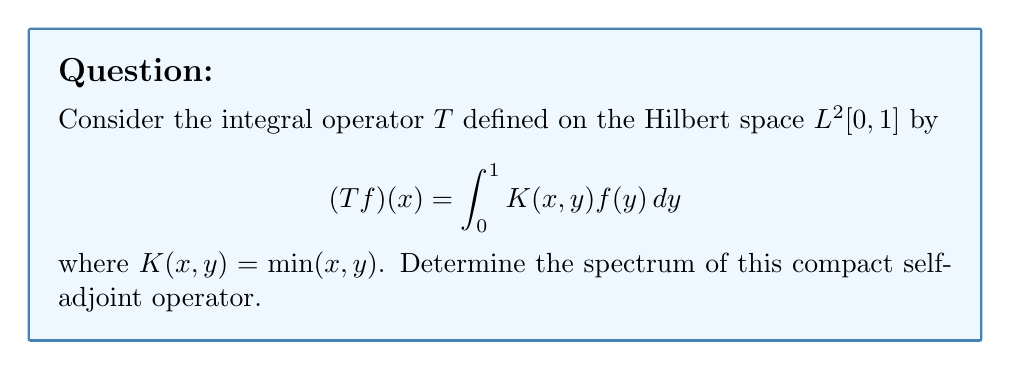Could you help me with this problem? 1) First, we recognize that this is a compact self-adjoint operator on $L^2[0,1]$. By the spectral theorem for compact self-adjoint operators, we know that the spectrum consists only of eigenvalues and possibly 0.

2) To find the eigenvalues, we need to solve the eigenvalue equation:

   $$(Tf)(x) = \lambda f(x)$$

   $$\int_0^1 \min(x,y)f(y)dy = \lambda f(x)$$

3) Differentiating both sides with respect to x:

   $$f(x) + \int_x^1 f(y)dy = \lambda f'(x)$$

4) Differentiating again:

   $$f'(x) - f(x) = \lambda f''(x)$$

5) This is a second-order differential equation. The general solution is:

   $$f(x) = A\sin(\frac{x}{\sqrt{\lambda}}) + B\cos(\frac{x}{\sqrt{\lambda}})$$

6) Applying the boundary conditions:
   
   At $x=0$: $f(0) = 0$ implies $B = 0$
   At $x=1$: $f(1) = 0$ implies $\sin(\frac{1}{\sqrt{\lambda}}) = 0$

7) The solutions to this equation are:

   $$\frac{1}{\sqrt{\lambda}} = n\pi, \quad n = 1,2,3,...$$

8) Therefore, the eigenvalues are:

   $$\lambda_n = \frac{1}{n^2\pi^2}, \quad n = 1,2,3,...$$

9) The spectrum of $T$ consists of these eigenvalues and 0 (as 0 is always in the spectrum of a compact operator on an infinite-dimensional space).
Answer: $\{\frac{1}{n^2\pi^2} : n \in \mathbb{N}\} \cup \{0\}$ 